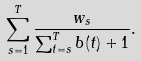<formula> <loc_0><loc_0><loc_500><loc_500>\sum _ { s = 1 } ^ { T } \frac { w _ { s } } { \sum _ { t = s } ^ { T } b ( t ) + 1 } .</formula> 